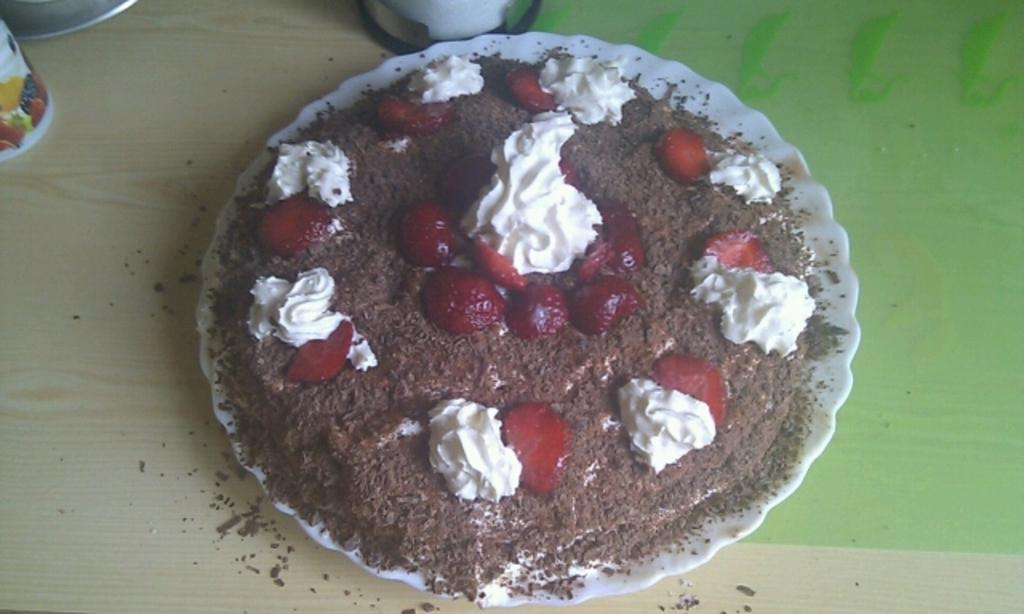What is the main food item featured in the image? There is a cake with strawberries on it in the image. How is the cake presented in the image? The cake is on a plate. Where is the plate located in the image? The plate is on a platform. What else can be seen on the platform in the image? There are other items on the platform. What type of minister is standing next to the cake in the image? There is no minister present in the image; it only features a cake with strawberries on a plate on a platform with other items. 